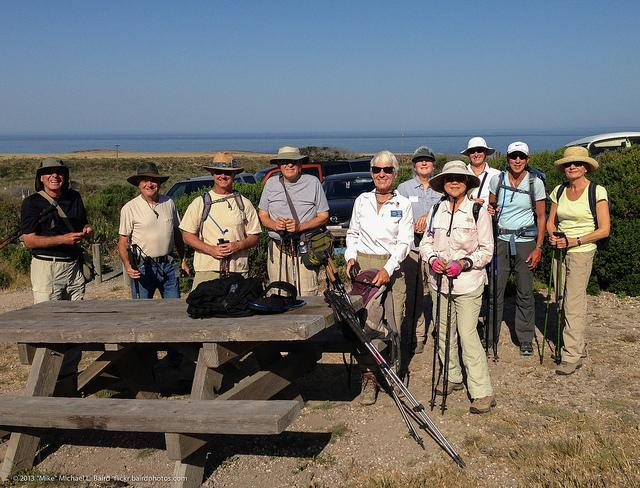What activity is this group preparing for?

Choices:
A) running
B) whale watching
C) sailing
D) hiking hiking 